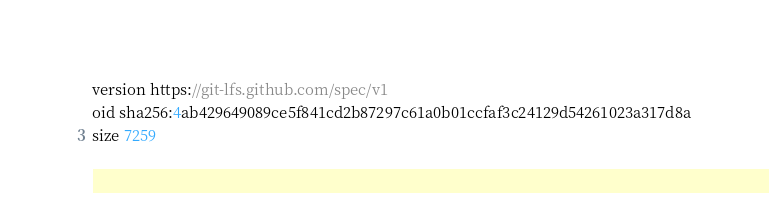Convert code to text. <code><loc_0><loc_0><loc_500><loc_500><_JavaScript_>version https://git-lfs.github.com/spec/v1
oid sha256:4ab429649089ce5f841cd2b87297c61a0b01ccfaf3c24129d54261023a317d8a
size 7259
</code> 